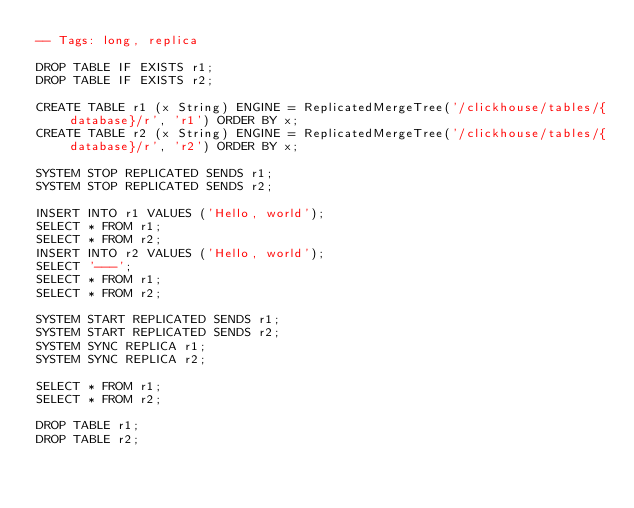Convert code to text. <code><loc_0><loc_0><loc_500><loc_500><_SQL_>-- Tags: long, replica

DROP TABLE IF EXISTS r1;
DROP TABLE IF EXISTS r2;

CREATE TABLE r1 (x String) ENGINE = ReplicatedMergeTree('/clickhouse/tables/{database}/r', 'r1') ORDER BY x;
CREATE TABLE r2 (x String) ENGINE = ReplicatedMergeTree('/clickhouse/tables/{database}/r', 'r2') ORDER BY x;

SYSTEM STOP REPLICATED SENDS r1;
SYSTEM STOP REPLICATED SENDS r2;

INSERT INTO r1 VALUES ('Hello, world');
SELECT * FROM r1;
SELECT * FROM r2;
INSERT INTO r2 VALUES ('Hello, world');
SELECT '---';
SELECT * FROM r1;
SELECT * FROM r2;

SYSTEM START REPLICATED SENDS r1;
SYSTEM START REPLICATED SENDS r2;
SYSTEM SYNC REPLICA r1;
SYSTEM SYNC REPLICA r2;

SELECT * FROM r1;
SELECT * FROM r2;

DROP TABLE r1;
DROP TABLE r2;
</code> 